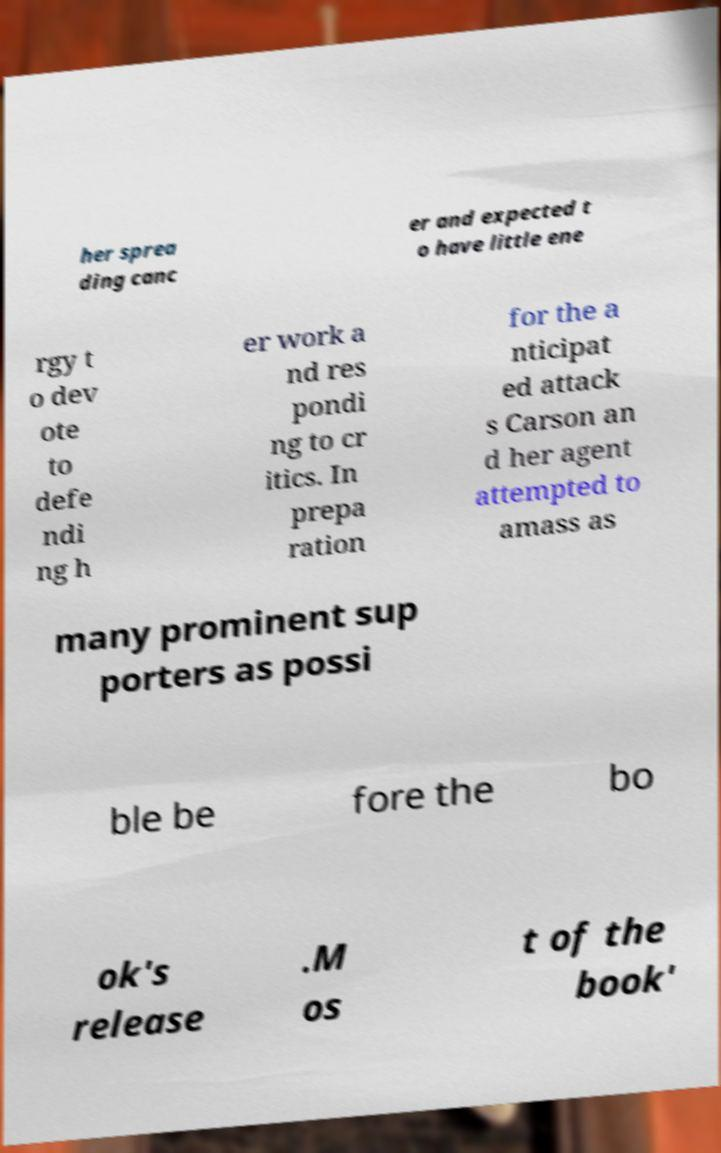Could you extract and type out the text from this image? her sprea ding canc er and expected t o have little ene rgy t o dev ote to defe ndi ng h er work a nd res pondi ng to cr itics. In prepa ration for the a nticipat ed attack s Carson an d her agent attempted to amass as many prominent sup porters as possi ble be fore the bo ok's release .M os t of the book' 